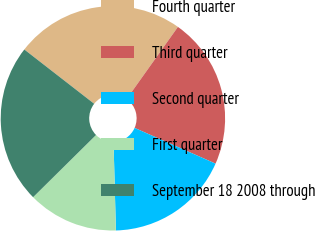<chart> <loc_0><loc_0><loc_500><loc_500><pie_chart><fcel>Fourth quarter<fcel>Third quarter<fcel>Second quarter<fcel>First quarter<fcel>September 18 2008 through<nl><fcel>24.33%<fcel>21.78%<fcel>17.96%<fcel>13.02%<fcel>22.92%<nl></chart> 